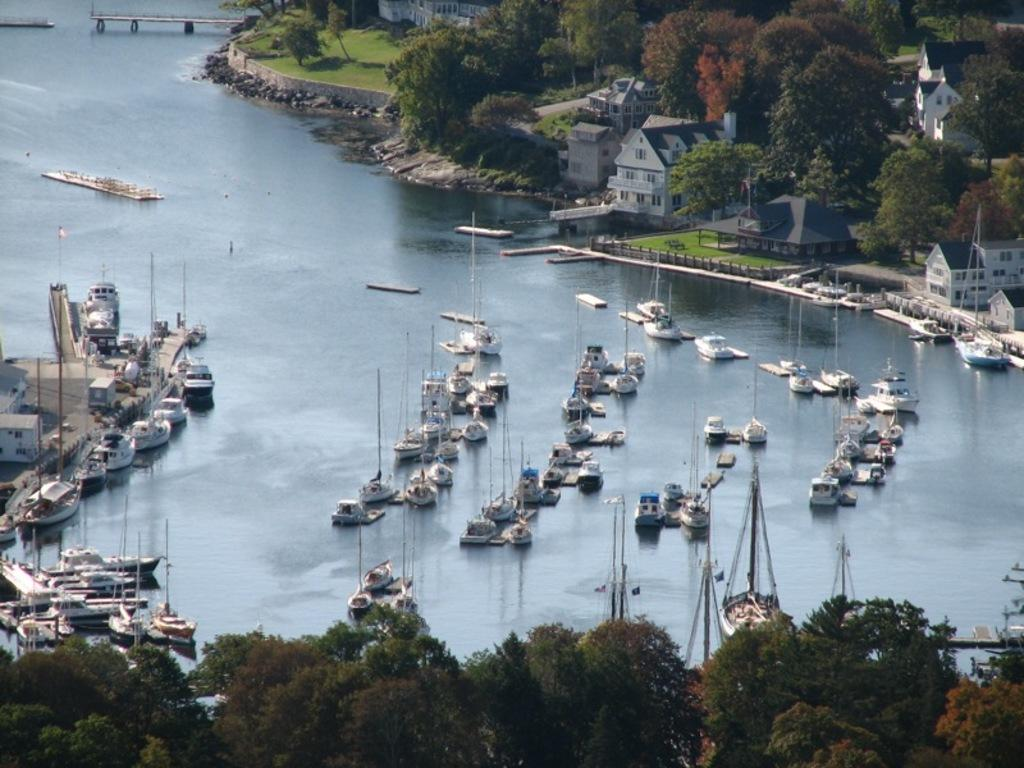What is the main element present in the image? There is water in the image. What can be seen floating on the water? There are boats in the image. What type of vegetation is visible in the image? There are trees in the image. What type of structures can be seen in the image? There are buildings in the image. What type of ground cover is present in the image? There is grass in the image. What type of barrier is present in the image? There is a fence in the image. What type of mint is growing on the fence in the image? There is no mint present in the image; it only features water, boats, trees, buildings, grass, and a fence. 